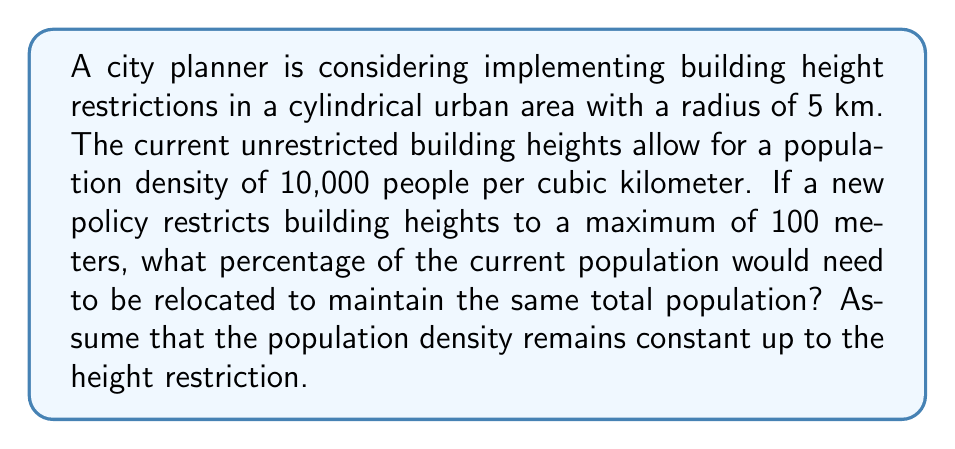Solve this math problem. To solve this problem, we need to compare the volumes of the cylindrical urban area before and after the height restriction. Let's break it down step by step:

1. Calculate the volume of the unrestricted cylindrical urban area:
   Let $h$ be the current average height of buildings.
   $$V_{unrestricted} = \pi r^2 h$$
   Where $r = 5$ km

2. Calculate the volume of the restricted cylindrical urban area:
   $$V_{restricted} = \pi r^2 \cdot 0.1$$
   (0.1 km = 100 meters)

3. Set up an equation based on the population density:
   $$10,000 \cdot V_{unrestricted} = 10,000 \cdot V_{restricted} + P_{relocated}$$
   Where $P_{relocated}$ is the number of people who need to be relocated.

4. Substitute the volume formulas:
   $$10,000 \cdot \pi r^2 h = 10,000 \cdot \pi r^2 \cdot 0.1 + P_{relocated}$$

5. Simplify and solve for $P_{relocated}$:
   $$P_{relocated} = 10,000 \cdot \pi r^2 (h - 0.1)$$

6. Calculate the percentage of population to be relocated:
   $$\text{Percentage} = \frac{P_{relocated}}{10,000 \cdot \pi r^2 h} \cdot 100\%$$

7. Simplify the percentage formula:
   $$\text{Percentage} = \frac{h - 0.1}{h} \cdot 100\%$$

8. The formula shows that the percentage depends only on the current average height $h$. To get a specific answer, we need to assume a value for $h$. Let's assume the current average height is 200 meters (0.2 km):

   $$\text{Percentage} = \frac{0.2 - 0.1}{0.2} \cdot 100\% = 50\%$$

This means that if the current average building height is 200 meters, 50% of the population would need to be relocated under the new height restriction.
Answer: Assuming a current average building height of 200 meters, 50% of the population would need to be relocated to maintain the same total population under the new height restriction of 100 meters. 